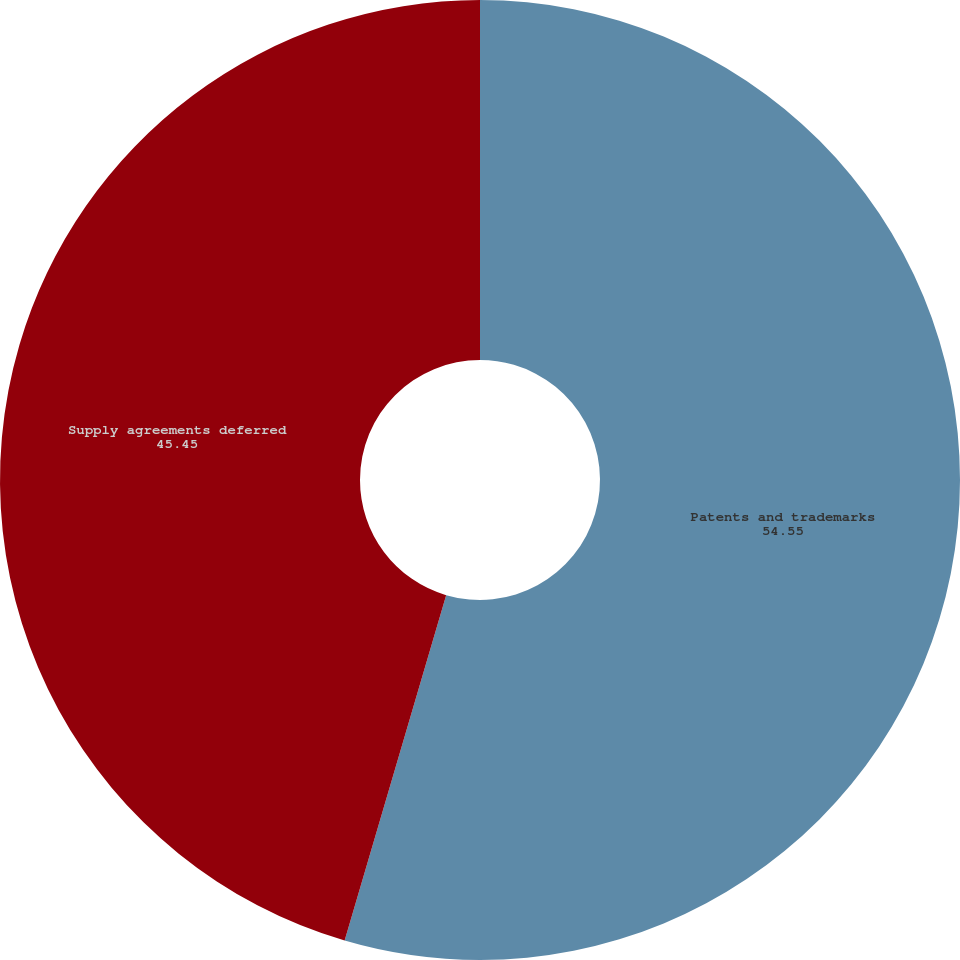<chart> <loc_0><loc_0><loc_500><loc_500><pie_chart><fcel>Patents and trademarks<fcel>Supply agreements deferred<nl><fcel>54.55%<fcel>45.45%<nl></chart> 